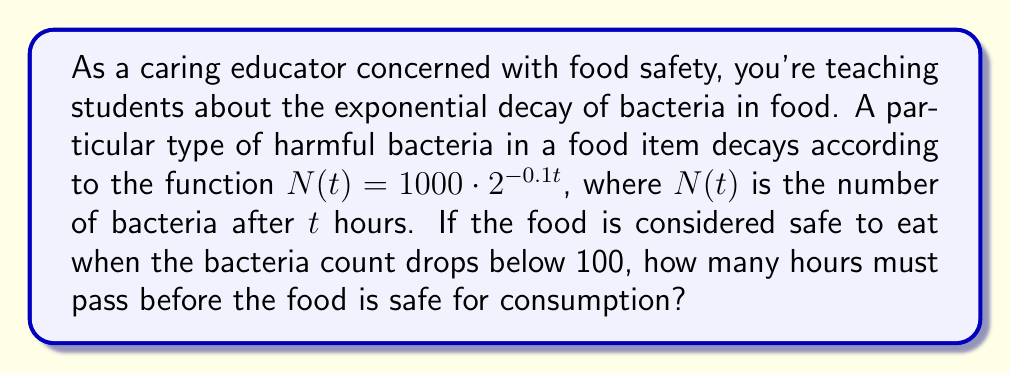Help me with this question. Let's approach this step-by-step:

1) We need to find $t$ when $N(t) < 100$. So, we set up the equation:

   $100 = 1000 \cdot 2^{-0.1t}$

2) Divide both sides by 1000:

   $\frac{1}{10} = 2^{-0.1t}$

3) Take the logarithm (base 2) of both sides:

   $\log_2(\frac{1}{10}) = \log_2(2^{-0.1t})$

4) Using the logarithm property $\log_a(x^n) = n\log_a(x)$, the right side simplifies to $-0.1t$:

   $\log_2(\frac{1}{10}) = -0.1t$

5) Solve for $t$:

   $t = -10 \log_2(\frac{1}{10})$

6) We can simplify this further:

   $t = -10 \log_2(\frac{1}{10}) = 10 \log_2(10)$

7) Using a calculator or logarithm table:

   $t \approx 33.22$ hours

Therefore, the food will be safe to eat after approximately 33.22 hours.
Answer: $t \approx 33.22$ hours 